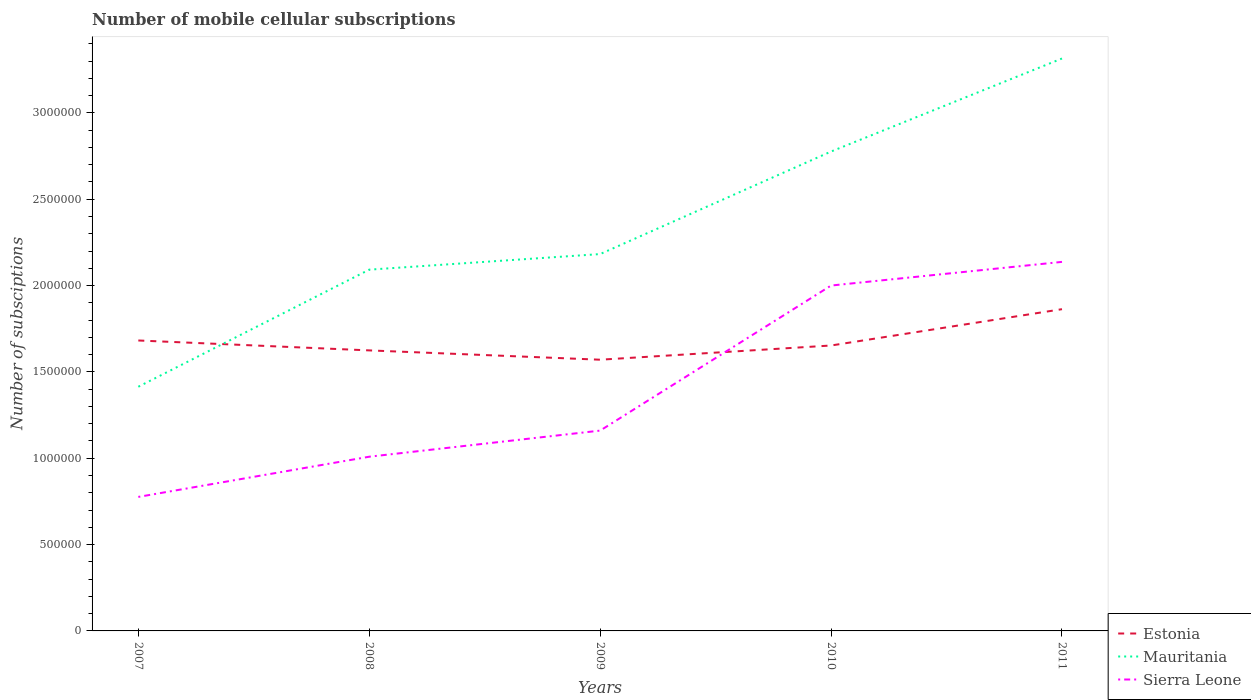Does the line corresponding to Mauritania intersect with the line corresponding to Estonia?
Ensure brevity in your answer.  Yes. Is the number of lines equal to the number of legend labels?
Give a very brief answer. Yes. Across all years, what is the maximum number of mobile cellular subscriptions in Sierra Leone?
Offer a terse response. 7.76e+05. In which year was the number of mobile cellular subscriptions in Sierra Leone maximum?
Provide a succinct answer. 2007. What is the total number of mobile cellular subscriptions in Sierra Leone in the graph?
Offer a very short reply. -1.37e+05. What is the difference between the highest and the second highest number of mobile cellular subscriptions in Sierra Leone?
Your response must be concise. 1.36e+06. What is the difference between the highest and the lowest number of mobile cellular subscriptions in Estonia?
Provide a short and direct response. 2. How many lines are there?
Keep it short and to the point. 3. How many years are there in the graph?
Your answer should be compact. 5. Does the graph contain any zero values?
Offer a terse response. No. Does the graph contain grids?
Make the answer very short. No. Where does the legend appear in the graph?
Ensure brevity in your answer.  Bottom right. How many legend labels are there?
Your answer should be very brief. 3. What is the title of the graph?
Make the answer very short. Number of mobile cellular subscriptions. Does "Lebanon" appear as one of the legend labels in the graph?
Offer a very short reply. No. What is the label or title of the Y-axis?
Provide a short and direct response. Number of subsciptions. What is the Number of subsciptions of Estonia in 2007?
Offer a terse response. 1.68e+06. What is the Number of subsciptions of Mauritania in 2007?
Provide a succinct answer. 1.41e+06. What is the Number of subsciptions of Sierra Leone in 2007?
Your response must be concise. 7.76e+05. What is the Number of subsciptions in Estonia in 2008?
Make the answer very short. 1.62e+06. What is the Number of subsciptions of Mauritania in 2008?
Give a very brief answer. 2.09e+06. What is the Number of subsciptions of Sierra Leone in 2008?
Provide a succinct answer. 1.01e+06. What is the Number of subsciptions in Estonia in 2009?
Provide a short and direct response. 1.57e+06. What is the Number of subsciptions of Mauritania in 2009?
Make the answer very short. 2.18e+06. What is the Number of subsciptions of Sierra Leone in 2009?
Provide a succinct answer. 1.16e+06. What is the Number of subsciptions of Estonia in 2010?
Give a very brief answer. 1.65e+06. What is the Number of subsciptions of Mauritania in 2010?
Provide a succinct answer. 2.78e+06. What is the Number of subsciptions in Estonia in 2011?
Offer a terse response. 1.86e+06. What is the Number of subsciptions of Mauritania in 2011?
Provide a short and direct response. 3.31e+06. What is the Number of subsciptions in Sierra Leone in 2011?
Offer a very short reply. 2.14e+06. Across all years, what is the maximum Number of subsciptions in Estonia?
Your answer should be very brief. 1.86e+06. Across all years, what is the maximum Number of subsciptions of Mauritania?
Provide a short and direct response. 3.31e+06. Across all years, what is the maximum Number of subsciptions in Sierra Leone?
Ensure brevity in your answer.  2.14e+06. Across all years, what is the minimum Number of subsciptions of Estonia?
Keep it short and to the point. 1.57e+06. Across all years, what is the minimum Number of subsciptions of Mauritania?
Make the answer very short. 1.41e+06. Across all years, what is the minimum Number of subsciptions of Sierra Leone?
Offer a terse response. 7.76e+05. What is the total Number of subsciptions of Estonia in the graph?
Keep it short and to the point. 8.39e+06. What is the total Number of subsciptions in Mauritania in the graph?
Your answer should be compact. 1.18e+07. What is the total Number of subsciptions of Sierra Leone in the graph?
Your answer should be very brief. 7.08e+06. What is the difference between the Number of subsciptions in Estonia in 2007 and that in 2008?
Offer a terse response. 5.74e+04. What is the difference between the Number of subsciptions in Mauritania in 2007 and that in 2008?
Make the answer very short. -6.78e+05. What is the difference between the Number of subsciptions of Sierra Leone in 2007 and that in 2008?
Your answer should be compact. -2.33e+05. What is the difference between the Number of subsciptions of Estonia in 2007 and that in 2009?
Ensure brevity in your answer.  1.11e+05. What is the difference between the Number of subsciptions of Mauritania in 2007 and that in 2009?
Offer a very short reply. -7.68e+05. What is the difference between the Number of subsciptions of Sierra Leone in 2007 and that in 2009?
Your response must be concise. -3.84e+05. What is the difference between the Number of subsciptions in Estonia in 2007 and that in 2010?
Make the answer very short. 2.90e+04. What is the difference between the Number of subsciptions in Mauritania in 2007 and that in 2010?
Provide a succinct answer. -1.36e+06. What is the difference between the Number of subsciptions in Sierra Leone in 2007 and that in 2010?
Give a very brief answer. -1.22e+06. What is the difference between the Number of subsciptions in Estonia in 2007 and that in 2011?
Ensure brevity in your answer.  -1.81e+05. What is the difference between the Number of subsciptions in Mauritania in 2007 and that in 2011?
Your answer should be compact. -1.90e+06. What is the difference between the Number of subsciptions of Sierra Leone in 2007 and that in 2011?
Offer a very short reply. -1.36e+06. What is the difference between the Number of subsciptions in Estonia in 2008 and that in 2009?
Offer a very short reply. 5.39e+04. What is the difference between the Number of subsciptions in Mauritania in 2008 and that in 2009?
Your answer should be very brief. -9.03e+04. What is the difference between the Number of subsciptions in Sierra Leone in 2008 and that in 2009?
Ensure brevity in your answer.  -1.51e+05. What is the difference between the Number of subsciptions of Estonia in 2008 and that in 2010?
Provide a succinct answer. -2.83e+04. What is the difference between the Number of subsciptions in Mauritania in 2008 and that in 2010?
Ensure brevity in your answer.  -6.84e+05. What is the difference between the Number of subsciptions in Sierra Leone in 2008 and that in 2010?
Ensure brevity in your answer.  -9.91e+05. What is the difference between the Number of subsciptions of Estonia in 2008 and that in 2011?
Provide a succinct answer. -2.39e+05. What is the difference between the Number of subsciptions in Mauritania in 2008 and that in 2011?
Provide a short and direct response. -1.22e+06. What is the difference between the Number of subsciptions of Sierra Leone in 2008 and that in 2011?
Your response must be concise. -1.13e+06. What is the difference between the Number of subsciptions in Estonia in 2009 and that in 2010?
Your response must be concise. -8.23e+04. What is the difference between the Number of subsciptions of Mauritania in 2009 and that in 2010?
Your response must be concise. -5.94e+05. What is the difference between the Number of subsciptions in Sierra Leone in 2009 and that in 2010?
Your answer should be very brief. -8.40e+05. What is the difference between the Number of subsciptions in Estonia in 2009 and that in 2011?
Ensure brevity in your answer.  -2.93e+05. What is the difference between the Number of subsciptions in Mauritania in 2009 and that in 2011?
Your answer should be very brief. -1.13e+06. What is the difference between the Number of subsciptions of Sierra Leone in 2009 and that in 2011?
Offer a very short reply. -9.77e+05. What is the difference between the Number of subsciptions of Estonia in 2010 and that in 2011?
Offer a very short reply. -2.10e+05. What is the difference between the Number of subsciptions of Mauritania in 2010 and that in 2011?
Provide a short and direct response. -5.39e+05. What is the difference between the Number of subsciptions of Sierra Leone in 2010 and that in 2011?
Your answer should be very brief. -1.37e+05. What is the difference between the Number of subsciptions in Estonia in 2007 and the Number of subsciptions in Mauritania in 2008?
Give a very brief answer. -4.10e+05. What is the difference between the Number of subsciptions in Estonia in 2007 and the Number of subsciptions in Sierra Leone in 2008?
Your answer should be compact. 6.73e+05. What is the difference between the Number of subsciptions in Mauritania in 2007 and the Number of subsciptions in Sierra Leone in 2008?
Offer a terse response. 4.05e+05. What is the difference between the Number of subsciptions of Estonia in 2007 and the Number of subsciptions of Mauritania in 2009?
Your answer should be compact. -5.00e+05. What is the difference between the Number of subsciptions in Estonia in 2007 and the Number of subsciptions in Sierra Leone in 2009?
Offer a very short reply. 5.22e+05. What is the difference between the Number of subsciptions in Mauritania in 2007 and the Number of subsciptions in Sierra Leone in 2009?
Provide a short and direct response. 2.54e+05. What is the difference between the Number of subsciptions of Estonia in 2007 and the Number of subsciptions of Mauritania in 2010?
Your response must be concise. -1.09e+06. What is the difference between the Number of subsciptions in Estonia in 2007 and the Number of subsciptions in Sierra Leone in 2010?
Provide a short and direct response. -3.18e+05. What is the difference between the Number of subsciptions of Mauritania in 2007 and the Number of subsciptions of Sierra Leone in 2010?
Keep it short and to the point. -5.86e+05. What is the difference between the Number of subsciptions of Estonia in 2007 and the Number of subsciptions of Mauritania in 2011?
Keep it short and to the point. -1.63e+06. What is the difference between the Number of subsciptions in Estonia in 2007 and the Number of subsciptions in Sierra Leone in 2011?
Your response must be concise. -4.55e+05. What is the difference between the Number of subsciptions in Mauritania in 2007 and the Number of subsciptions in Sierra Leone in 2011?
Offer a very short reply. -7.23e+05. What is the difference between the Number of subsciptions in Estonia in 2008 and the Number of subsciptions in Mauritania in 2009?
Provide a succinct answer. -5.58e+05. What is the difference between the Number of subsciptions of Estonia in 2008 and the Number of subsciptions of Sierra Leone in 2009?
Provide a short and direct response. 4.64e+05. What is the difference between the Number of subsciptions in Mauritania in 2008 and the Number of subsciptions in Sierra Leone in 2009?
Make the answer very short. 9.32e+05. What is the difference between the Number of subsciptions of Estonia in 2008 and the Number of subsciptions of Mauritania in 2010?
Your answer should be very brief. -1.15e+06. What is the difference between the Number of subsciptions of Estonia in 2008 and the Number of subsciptions of Sierra Leone in 2010?
Offer a very short reply. -3.76e+05. What is the difference between the Number of subsciptions of Mauritania in 2008 and the Number of subsciptions of Sierra Leone in 2010?
Your response must be concise. 9.20e+04. What is the difference between the Number of subsciptions of Estonia in 2008 and the Number of subsciptions of Mauritania in 2011?
Offer a terse response. -1.69e+06. What is the difference between the Number of subsciptions in Estonia in 2008 and the Number of subsciptions in Sierra Leone in 2011?
Your answer should be compact. -5.13e+05. What is the difference between the Number of subsciptions of Mauritania in 2008 and the Number of subsciptions of Sierra Leone in 2011?
Your answer should be very brief. -4.50e+04. What is the difference between the Number of subsciptions in Estonia in 2009 and the Number of subsciptions in Mauritania in 2010?
Provide a succinct answer. -1.21e+06. What is the difference between the Number of subsciptions in Estonia in 2009 and the Number of subsciptions in Sierra Leone in 2010?
Offer a terse response. -4.29e+05. What is the difference between the Number of subsciptions of Mauritania in 2009 and the Number of subsciptions of Sierra Leone in 2010?
Give a very brief answer. 1.82e+05. What is the difference between the Number of subsciptions of Estonia in 2009 and the Number of subsciptions of Mauritania in 2011?
Your answer should be very brief. -1.74e+06. What is the difference between the Number of subsciptions in Estonia in 2009 and the Number of subsciptions in Sierra Leone in 2011?
Give a very brief answer. -5.66e+05. What is the difference between the Number of subsciptions of Mauritania in 2009 and the Number of subsciptions of Sierra Leone in 2011?
Your response must be concise. 4.52e+04. What is the difference between the Number of subsciptions in Estonia in 2010 and the Number of subsciptions in Mauritania in 2011?
Offer a terse response. -1.66e+06. What is the difference between the Number of subsciptions of Estonia in 2010 and the Number of subsciptions of Sierra Leone in 2011?
Offer a terse response. -4.84e+05. What is the difference between the Number of subsciptions of Mauritania in 2010 and the Number of subsciptions of Sierra Leone in 2011?
Make the answer very short. 6.39e+05. What is the average Number of subsciptions of Estonia per year?
Give a very brief answer. 1.68e+06. What is the average Number of subsciptions of Mauritania per year?
Your answer should be compact. 2.36e+06. What is the average Number of subsciptions in Sierra Leone per year?
Give a very brief answer. 1.42e+06. In the year 2007, what is the difference between the Number of subsciptions in Estonia and Number of subsciptions in Mauritania?
Make the answer very short. 2.68e+05. In the year 2007, what is the difference between the Number of subsciptions of Estonia and Number of subsciptions of Sierra Leone?
Offer a terse response. 9.06e+05. In the year 2007, what is the difference between the Number of subsciptions in Mauritania and Number of subsciptions in Sierra Leone?
Your answer should be very brief. 6.38e+05. In the year 2008, what is the difference between the Number of subsciptions of Estonia and Number of subsciptions of Mauritania?
Your answer should be compact. -4.68e+05. In the year 2008, what is the difference between the Number of subsciptions in Estonia and Number of subsciptions in Sierra Leone?
Give a very brief answer. 6.16e+05. In the year 2008, what is the difference between the Number of subsciptions of Mauritania and Number of subsciptions of Sierra Leone?
Your answer should be compact. 1.08e+06. In the year 2009, what is the difference between the Number of subsciptions of Estonia and Number of subsciptions of Mauritania?
Give a very brief answer. -6.12e+05. In the year 2009, what is the difference between the Number of subsciptions in Estonia and Number of subsciptions in Sierra Leone?
Your response must be concise. 4.11e+05. In the year 2009, what is the difference between the Number of subsciptions in Mauritania and Number of subsciptions in Sierra Leone?
Offer a very short reply. 1.02e+06. In the year 2010, what is the difference between the Number of subsciptions in Estonia and Number of subsciptions in Mauritania?
Provide a succinct answer. -1.12e+06. In the year 2010, what is the difference between the Number of subsciptions in Estonia and Number of subsciptions in Sierra Leone?
Give a very brief answer. -3.47e+05. In the year 2010, what is the difference between the Number of subsciptions in Mauritania and Number of subsciptions in Sierra Leone?
Your answer should be very brief. 7.76e+05. In the year 2011, what is the difference between the Number of subsciptions in Estonia and Number of subsciptions in Mauritania?
Make the answer very short. -1.45e+06. In the year 2011, what is the difference between the Number of subsciptions of Estonia and Number of subsciptions of Sierra Leone?
Give a very brief answer. -2.74e+05. In the year 2011, what is the difference between the Number of subsciptions in Mauritania and Number of subsciptions in Sierra Leone?
Your response must be concise. 1.18e+06. What is the ratio of the Number of subsciptions in Estonia in 2007 to that in 2008?
Your answer should be very brief. 1.04. What is the ratio of the Number of subsciptions in Mauritania in 2007 to that in 2008?
Your answer should be very brief. 0.68. What is the ratio of the Number of subsciptions of Sierra Leone in 2007 to that in 2008?
Your answer should be very brief. 0.77. What is the ratio of the Number of subsciptions in Estonia in 2007 to that in 2009?
Your response must be concise. 1.07. What is the ratio of the Number of subsciptions of Mauritania in 2007 to that in 2009?
Your response must be concise. 0.65. What is the ratio of the Number of subsciptions of Sierra Leone in 2007 to that in 2009?
Your answer should be very brief. 0.67. What is the ratio of the Number of subsciptions of Estonia in 2007 to that in 2010?
Provide a short and direct response. 1.02. What is the ratio of the Number of subsciptions in Mauritania in 2007 to that in 2010?
Provide a succinct answer. 0.51. What is the ratio of the Number of subsciptions in Sierra Leone in 2007 to that in 2010?
Offer a terse response. 0.39. What is the ratio of the Number of subsciptions of Estonia in 2007 to that in 2011?
Keep it short and to the point. 0.9. What is the ratio of the Number of subsciptions of Mauritania in 2007 to that in 2011?
Ensure brevity in your answer.  0.43. What is the ratio of the Number of subsciptions in Sierra Leone in 2007 to that in 2011?
Offer a very short reply. 0.36. What is the ratio of the Number of subsciptions in Estonia in 2008 to that in 2009?
Provide a succinct answer. 1.03. What is the ratio of the Number of subsciptions of Mauritania in 2008 to that in 2009?
Provide a succinct answer. 0.96. What is the ratio of the Number of subsciptions in Sierra Leone in 2008 to that in 2009?
Ensure brevity in your answer.  0.87. What is the ratio of the Number of subsciptions in Estonia in 2008 to that in 2010?
Offer a very short reply. 0.98. What is the ratio of the Number of subsciptions of Mauritania in 2008 to that in 2010?
Provide a short and direct response. 0.75. What is the ratio of the Number of subsciptions in Sierra Leone in 2008 to that in 2010?
Make the answer very short. 0.5. What is the ratio of the Number of subsciptions in Estonia in 2008 to that in 2011?
Your answer should be very brief. 0.87. What is the ratio of the Number of subsciptions in Mauritania in 2008 to that in 2011?
Your answer should be very brief. 0.63. What is the ratio of the Number of subsciptions of Sierra Leone in 2008 to that in 2011?
Offer a very short reply. 0.47. What is the ratio of the Number of subsciptions in Estonia in 2009 to that in 2010?
Make the answer very short. 0.95. What is the ratio of the Number of subsciptions of Mauritania in 2009 to that in 2010?
Provide a short and direct response. 0.79. What is the ratio of the Number of subsciptions in Sierra Leone in 2009 to that in 2010?
Give a very brief answer. 0.58. What is the ratio of the Number of subsciptions in Estonia in 2009 to that in 2011?
Keep it short and to the point. 0.84. What is the ratio of the Number of subsciptions in Mauritania in 2009 to that in 2011?
Offer a very short reply. 0.66. What is the ratio of the Number of subsciptions in Sierra Leone in 2009 to that in 2011?
Offer a very short reply. 0.54. What is the ratio of the Number of subsciptions of Estonia in 2010 to that in 2011?
Provide a succinct answer. 0.89. What is the ratio of the Number of subsciptions of Mauritania in 2010 to that in 2011?
Give a very brief answer. 0.84. What is the ratio of the Number of subsciptions of Sierra Leone in 2010 to that in 2011?
Provide a succinct answer. 0.94. What is the difference between the highest and the second highest Number of subsciptions of Estonia?
Ensure brevity in your answer.  1.81e+05. What is the difference between the highest and the second highest Number of subsciptions in Mauritania?
Provide a succinct answer. 5.39e+05. What is the difference between the highest and the second highest Number of subsciptions of Sierra Leone?
Offer a very short reply. 1.37e+05. What is the difference between the highest and the lowest Number of subsciptions in Estonia?
Make the answer very short. 2.93e+05. What is the difference between the highest and the lowest Number of subsciptions in Mauritania?
Your answer should be compact. 1.90e+06. What is the difference between the highest and the lowest Number of subsciptions of Sierra Leone?
Make the answer very short. 1.36e+06. 